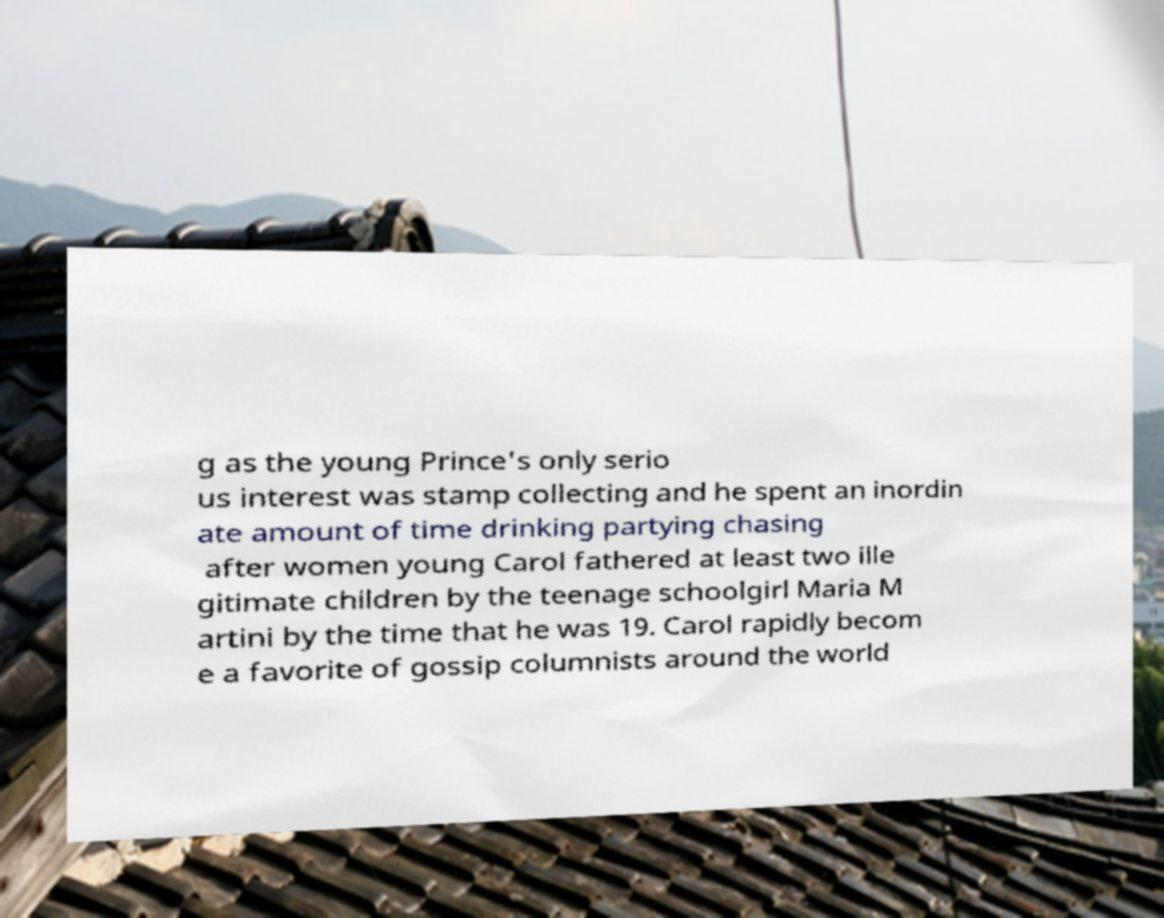Please identify and transcribe the text found in this image. g as the young Prince's only serio us interest was stamp collecting and he spent an inordin ate amount of time drinking partying chasing after women young Carol fathered at least two ille gitimate children by the teenage schoolgirl Maria M artini by the time that he was 19. Carol rapidly becom e a favorite of gossip columnists around the world 